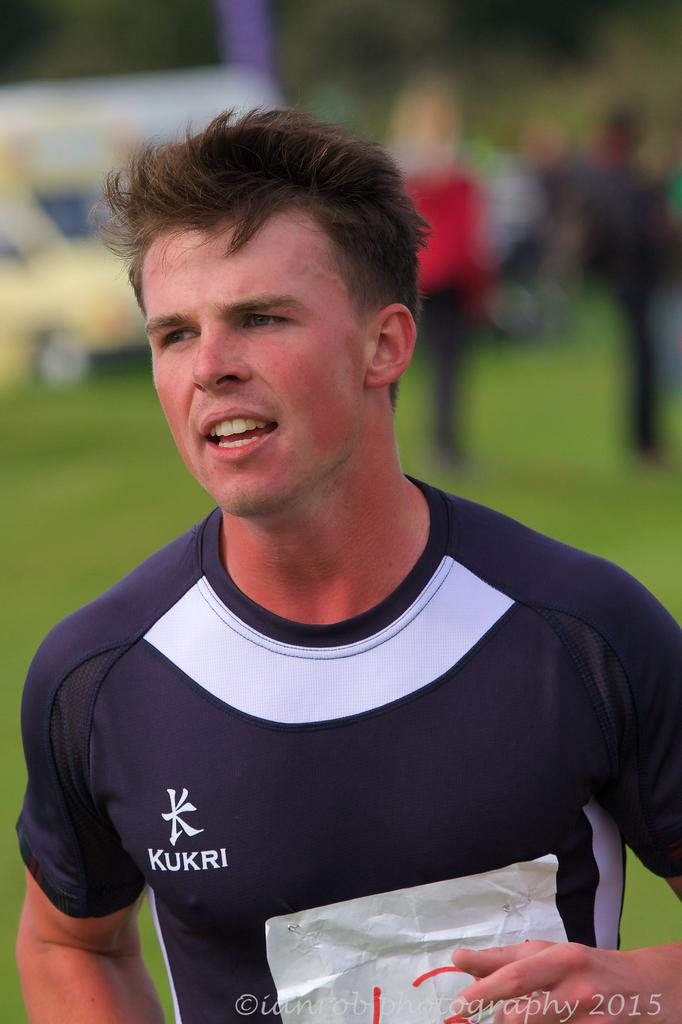<image>
Create a compact narrative representing the image presented. the name kukri that is on a jersey 